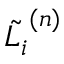<formula> <loc_0><loc_0><loc_500><loc_500>\tilde { L _ { i } } ^ { ( n ) }</formula> 